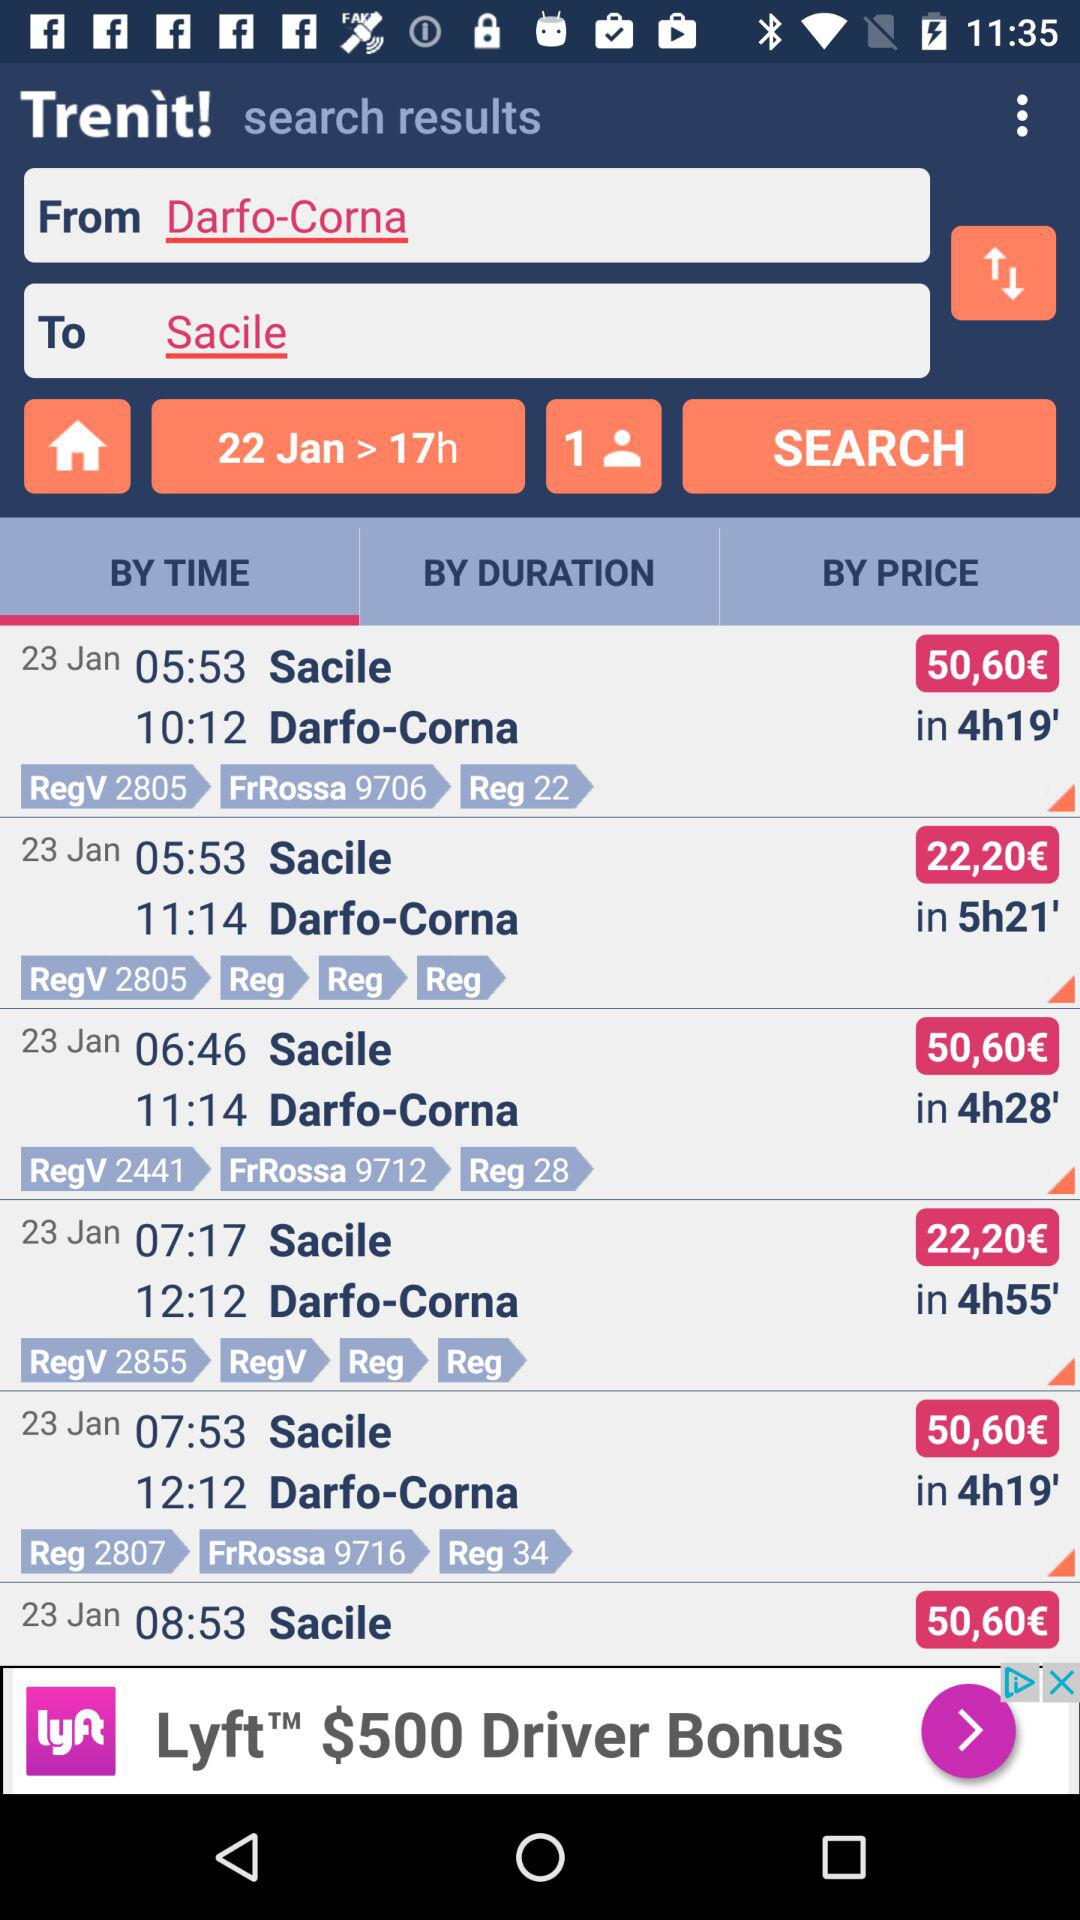What is the result date? The result date is 23 January. 